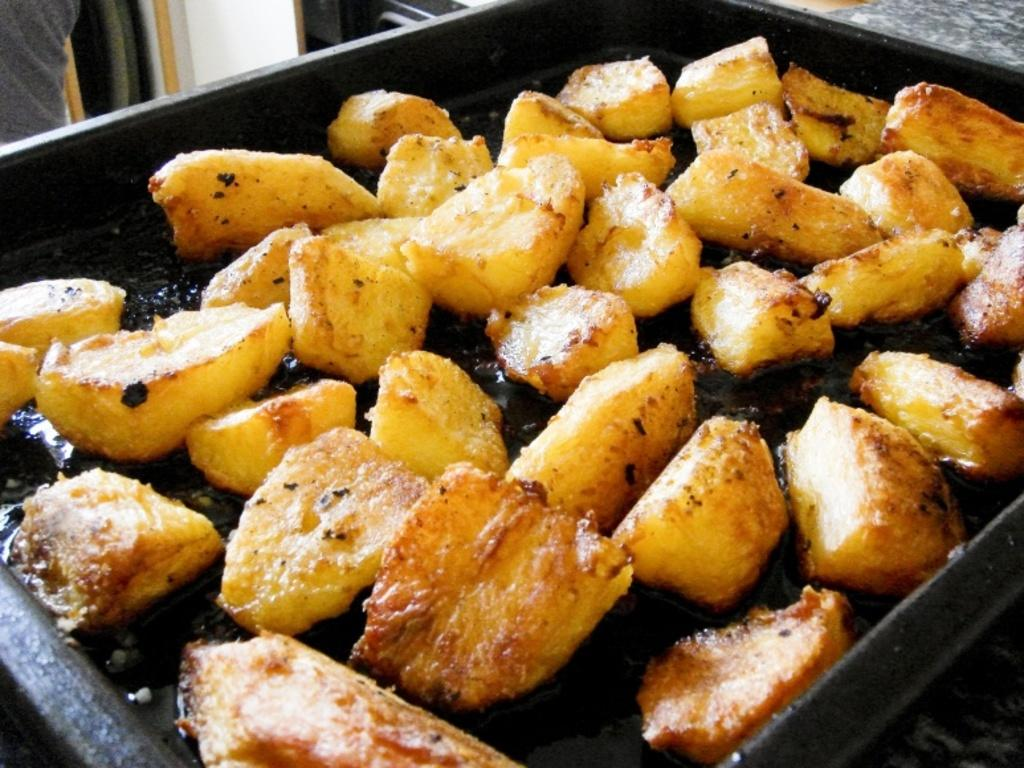What object is present in the image that is used for holding items? There is a tray in the image that is used for holding items. Where is the tray located in the image? The tray is on a tree in the image. What type of items can be seen on the tray? There are food items on the tray. How many waves can be seen crashing against the cave in the image? There is no cave or waves present in the image; it features a tray with food items on a tree. 